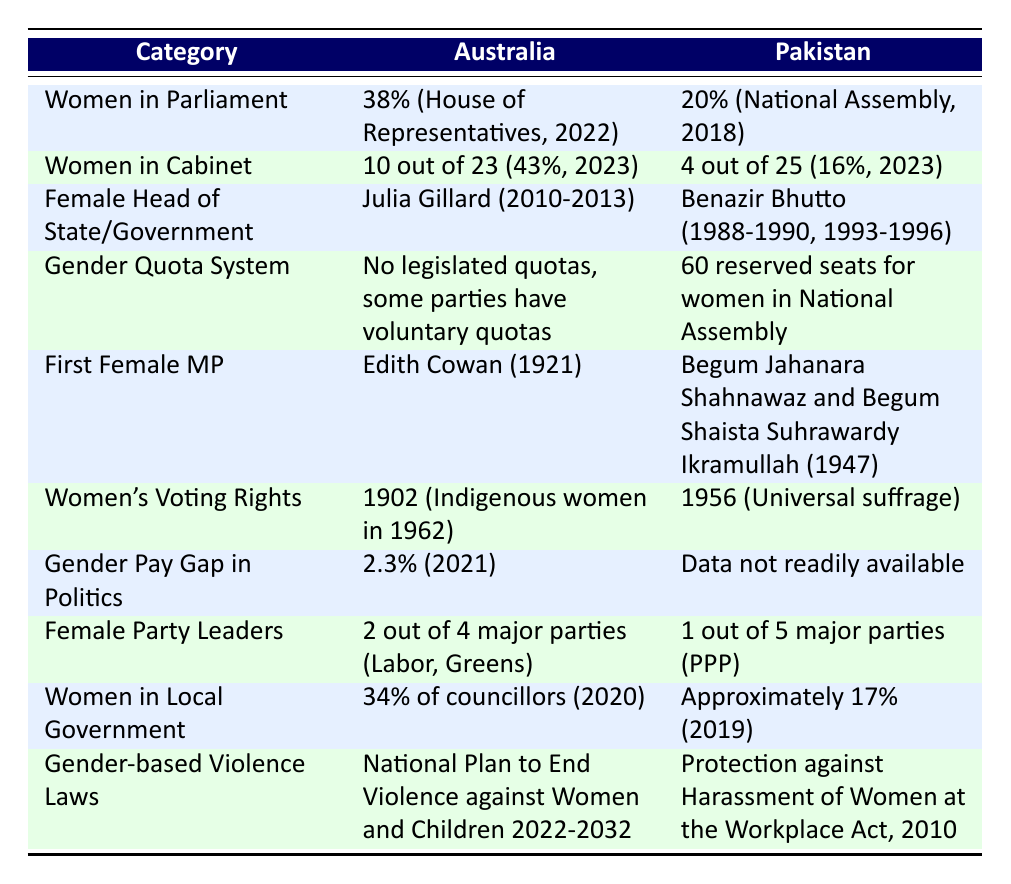What percentage of women are in the House of Representatives in Australia? According to the table, the percentage of women in the House of Representatives in Australia is given as 38% for the year 2022.
Answer: 38% How many women are in the Cabinet of Pakistan? The table states that there are 4 women out of 25 members in the Cabinet of Pakistan for the year 2023, which corresponds to 16%.
Answer: 4 out of 25 Was Julia Gillard the first female Prime Minister of Australia? The table indicates that Julia Gillard served as Prime Minister from 2010 to 2013, but does not specify if she was the first female Prime Minister. From external knowledge, we know she was the first. However, the table only confirms her term, not her status as first.
Answer: No Which country has a higher percentage of women in local government? In the table, Australia is reported to have 34% of councillors in local government as of 2020, whereas Pakistan has approximately 17% in 2019. Therefore, Australia has a higher percentage of women in local government.
Answer: Australia What is the difference in the representation of women in Parliament between Australia and Pakistan? The representation in Australia is 38% and in Pakistan, it is 20%. To find the difference, subtract Pakistan's percentage from Australia's: 38% - 20% = 18%.
Answer: 18% Is there a legislated gender quota system in Australia? The table indicates that Australia has no legislated quotas but mentions that some parties have voluntary quotas. Therefore, the answer is no, there isn't a legislated system.
Answer: No Which country has provided data on the gender pay gap in politics? The table shows that Australia has a gender pay gap of 2.3% as of 2021, while Pakistan mentions that the data is not readily available. Thus, Australia provides the relevant data.
Answer: Australia What was the year when universal suffrage was granted in Pakistan? According to the table, universal suffrage was granted in Pakistan in 1956, which indicates when all eligible adults were allowed to vote regardless of gender.
Answer: 1956 Which country had its first female MP earlier, Australia or Pakistan? The table notes that Australia had its first female MP, Edith Cowan, in 1921, while Pakistan had Begum Jahanara Shahnawaz and Begum Shaista Suhrawardy Ikramullah as its first female MPs in 1947. Since 1921 is earlier than 1947, Australia had its first female MP first.
Answer: Australia 